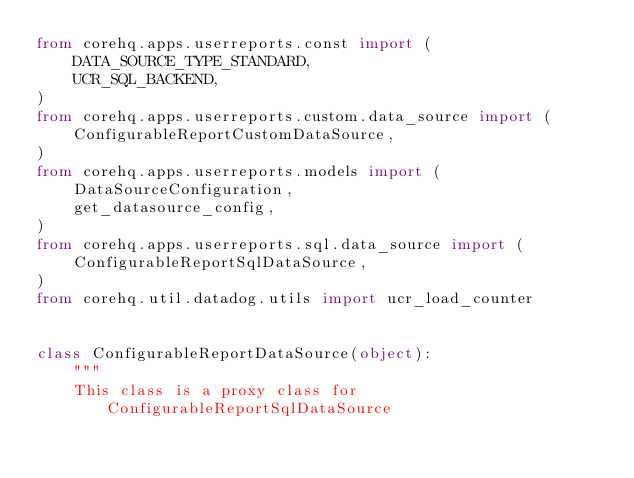<code> <loc_0><loc_0><loc_500><loc_500><_Python_>from corehq.apps.userreports.const import (
    DATA_SOURCE_TYPE_STANDARD,
    UCR_SQL_BACKEND,
)
from corehq.apps.userreports.custom.data_source import (
    ConfigurableReportCustomDataSource,
)
from corehq.apps.userreports.models import (
    DataSourceConfiguration,
    get_datasource_config,
)
from corehq.apps.userreports.sql.data_source import (
    ConfigurableReportSqlDataSource,
)
from corehq.util.datadog.utils import ucr_load_counter


class ConfigurableReportDataSource(object):
    """
    This class is a proxy class for ConfigurableReportSqlDataSource</code> 